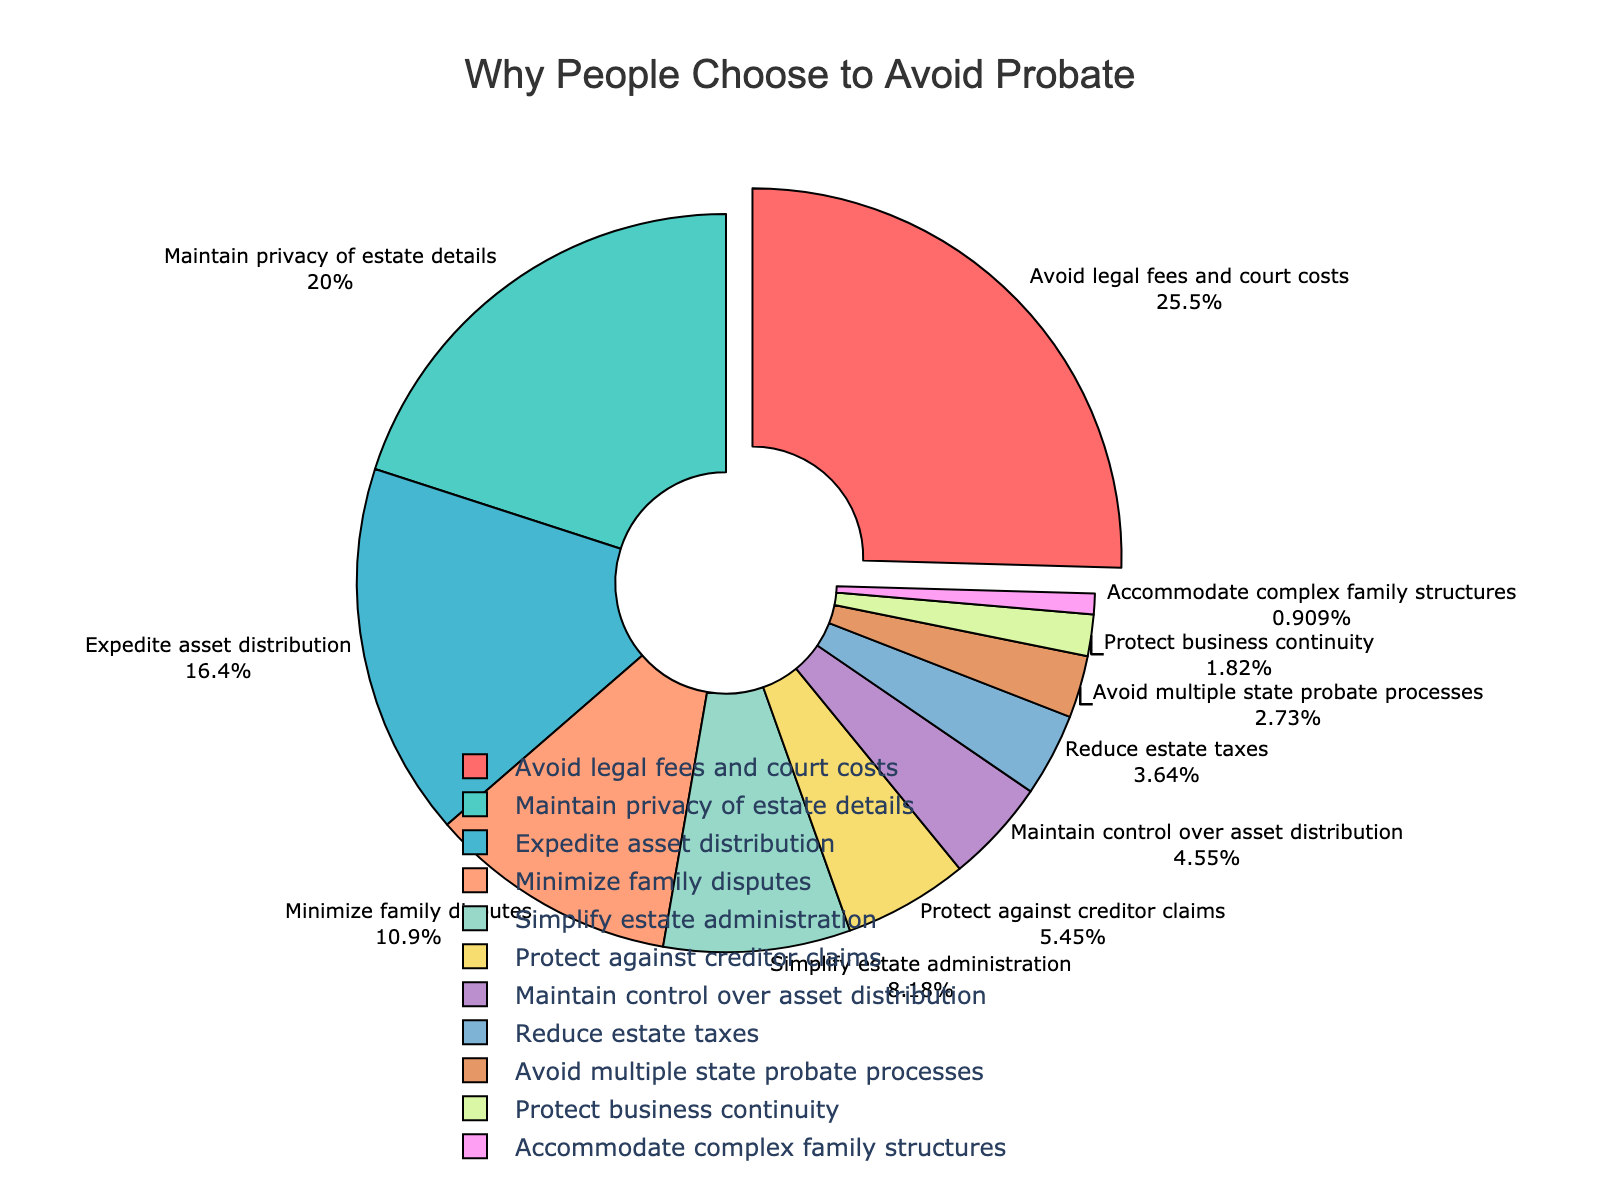Which reason has the highest percentage for avoiding probate? The reason with the highest percentage is the one that has the largest slice on the pie chart and is pulled out slightly from the rest. The corresponding label on the chart shows "Avoid legal fees and court costs" with 28%.
Answer: Avoid legal fees and court costs Which two reasons combined make up exactly 30% of the reasons for avoiding probate? From the pie chart, "Reduce estate taxes" has 4% and "Avoid multiple state probate processes" has 3%. These sum to 7%. However, combining "Avoid multiple state probate processes" (3%) and "Protect against creditor claims" (6%) equals 9%, and adding "Simplify estate administration" (9%) brings it to 18%, adding "Minimize family disputes" (12%) yields 30%.
Answer: Minimize family disputes and Simplify estate administration What is the difference in percentage between "Maintain control over asset distribution" and "Protect business continuity"? The pie chart shows that "Maintain control over asset distribution" is 5% and "Protect business continuity" is 2%. The difference is calculated as 5% - 2%.
Answer: 3% Which three reasons together account for more than 50% of the total? The chart shows "Avoid legal fees and court costs" at 28%, "Maintain privacy of estate details" at 22%, and "Expedite asset distribution" at 18%. Adding these percentages gives 28% + 22% + 18% = 68%, which is more than 50%.
Answer: Avoid legal fees and court costs, Maintain privacy of estate details, Expedite asset distribution Which reason has the smallest percentage, and what is that percentage? The smallest slice in the pie chart represents the reason "Accommodate complex family structures," which shows a percentage of 1%.
Answer: Accommodate complex family structures, 1% How much more common is "Expedite asset distribution" compared to "Protect against creditor claims"? The pie chart depicts "Expedite asset distribution" at 18% and "Protect against creditor claims" at 6%. The difference is 18% - 6%.
Answer: 12% How does the percentage of "Maintain privacy of estate details" compare to the combined percentage of "Maintain control over asset distribution" and "Reduce estate taxes"? "Maintain privacy of estate details" is at 22%. "Maintain control over asset distribution" is 5% and "Reduce estate taxes" is 4%. Combined, they are 5% + 4% = 9%, which is less than 22%.
Answer: Greater than What percentage of reasons listed are each 5% or less? The reasons with percentages 5% or less are "Maintain control over asset distribution" (5%), "Reduce estate taxes" (4%), "Avoid multiple state probate processes" (3%), "Protect business continuity" (2%), and "Accommodate complex family structures" (1%). The total number of reasons listed is 11. The portion with 5% or less is 5/11.
Answer: 45.45% 